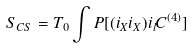<formula> <loc_0><loc_0><loc_500><loc_500>S _ { C S } = T _ { 0 } \int P [ ( i _ { X } i _ { X } ) i _ { l } C ^ { ( 4 ) } ]</formula> 